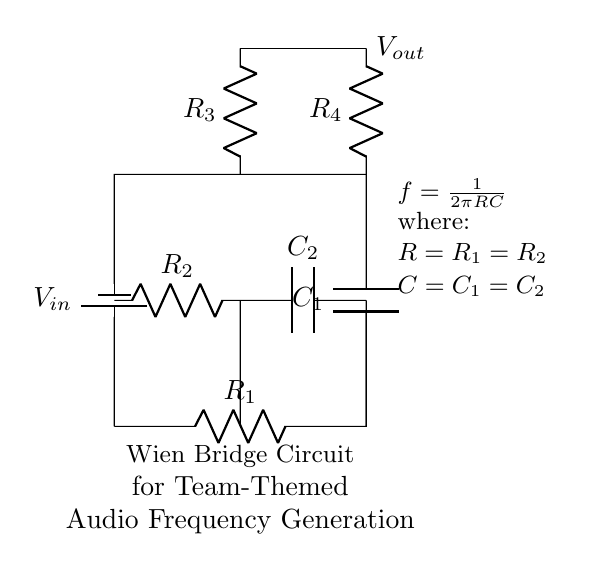What type of circuit is shown in the diagram? The circuit shown is a Wien Bridge Circuit, recognizable by the specific arrangement of resistors and capacitors that create a bridge for generating audio frequencies.
Answer: Wien Bridge Circuit What are the components used in the circuit? The components in the circuit include resistors and capacitors, specifically labeled as R1, R2, R3, R4, C1, and C2.
Answer: Resistors and capacitors What is the formula for frequency in this circuit? The formula for frequency is given as f = 1/(2πRC), indicating that frequency is inversely proportional to the product of resistance and capacitance in the circuit.
Answer: f = 1/(2πRC) What is the value of R1 relative to R2? R1 is equal to R2 as indicated in the explanation section below the circuit, showing that they share the same value for the circuit's functioning.
Answer: Equal What happens to the frequency if the capacitance C is increased? If capacitance C is increased, the frequency f will decrease, based on the formula where frequency is inversely proportional to capacitance.
Answer: Decrease How many resistors are present in the circuit? There are four resistors labeled R1, R2, R3, and R4, as can be counted directly in the circuit diagram.
Answer: Four Which two components are in series in the circuit? R2 and C2 are in series as they are directly connected end to end without any branching, forming a series path.
Answer: R2 and C2 